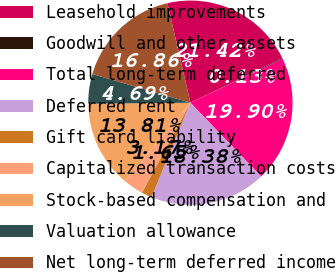Convert chart. <chart><loc_0><loc_0><loc_500><loc_500><pie_chart><fcel>Leasehold improvements<fcel>Goodwill and other assets<fcel>Total long-term deferred<fcel>Deferred rent<fcel>Gift card liability<fcel>Capitalized transaction costs<fcel>Stock-based compensation and<fcel>Valuation allowance<fcel>Net long-term deferred income<nl><fcel>21.42%<fcel>0.13%<fcel>19.9%<fcel>18.38%<fcel>1.65%<fcel>3.17%<fcel>13.81%<fcel>4.69%<fcel>16.86%<nl></chart> 